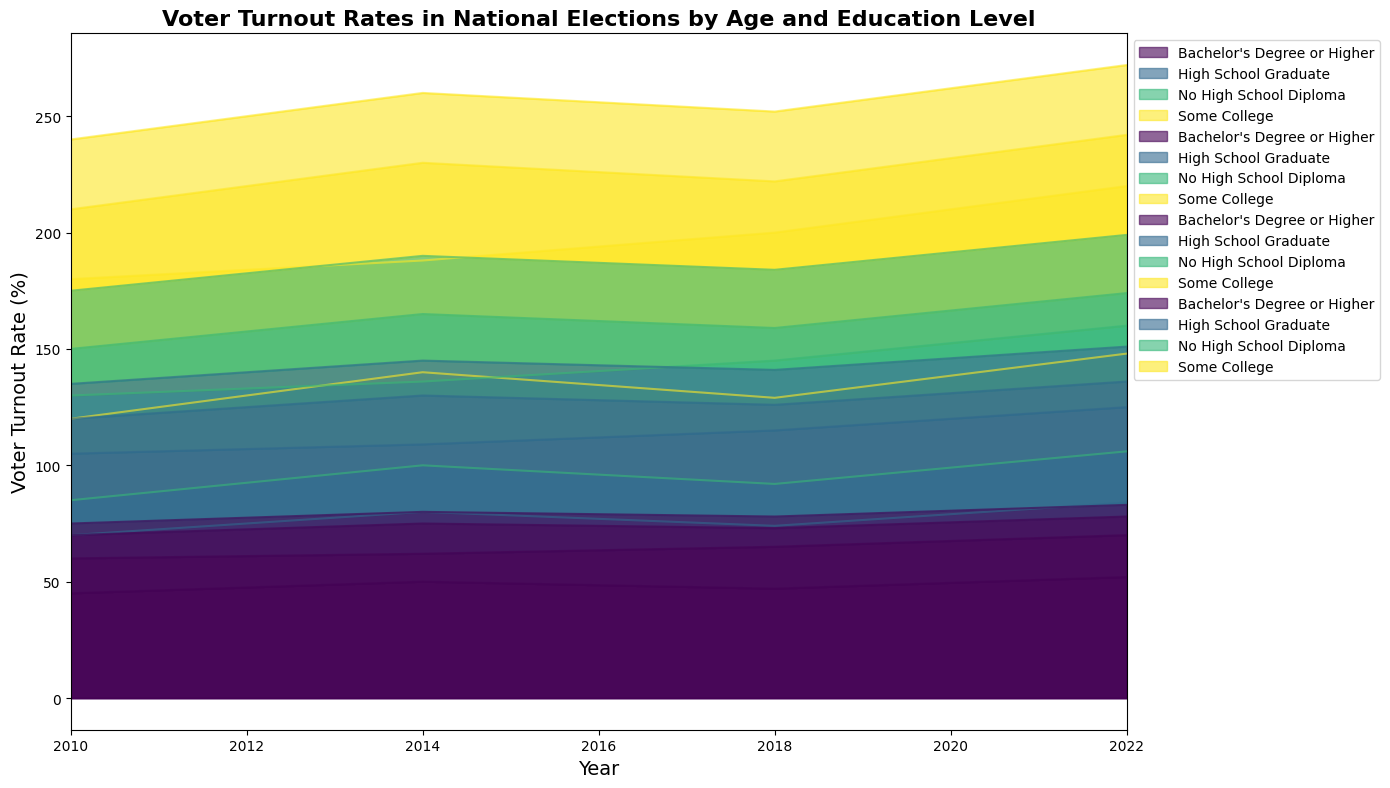What's the overall trend in voter turnout rates over the years for the 18-29 age group with no high school diploma? To determine the trend, look at the area representing the 18-29 age group with no high school diploma on the chart from 2010 to 2022. We can observe the color section related to this group. From 2010 to 2022, the rate shows an increase from 15.0% in 2010 to 22.0% in 2022.
Answer: Increasing How does the voter turnout rate of 60+ age group with a Bachelor's degree or higher in 2022 compare to the turnout rate of the same group in 2010? Identify the area representing the 60+ age group with a Bachelor's degree or higher in the years 2022 and 2010. The turnout rate for this group in 2010 is 75.0% and in 2022 is 83.0%.
Answer: Higher in 2022 Which education level saw the most significant increase in voter turnout for the 30-44 age group from 2010 to 2022? Examine the voter turnout rates for each education level within the 30-44 age group over the years. Calculate the rate of change for each education level between 2010 and 2022. The increases are: No HS Diploma (35.0 - 25.0) = 10.0, HS Graduate (55.0 - 45.0) = 10.0, Some College (60.0 - 50.0) = 10.0, Bachelor's Degree or Higher (70.0 - 60.0) = 10.0.
Answer: All levels saw significant increases of 10.0% What was the difference in voter turnout rates between the 45-59 age group with some college education and the 60+ age group with no high school diploma in 2018? For 2018, find the voter turnout rate for the 45-59 age group with some college education, which is 63.0%, and the rate for the 60+ age group with no high school diploma, which is 43.0%. Then, calculate the difference: 63.0 - 43.0 = 20.0.
Answer: 20.0% In 2022, which age group had the highest voter turnout rate for individuals with a high school diploma? Examine the voter turnout rates in 2022 for each age group with a high school diploma. The rates are: 18-29 (32.0%), 30-44 (55.0%), 45-59 (58.0%), 60+ (68.0%). The highest is the 60+ age group.
Answer: 60+ What's the average voter turnout rate for the 45-59 age group across all education levels in 2014? Find the voter turnout rates for each education level within the 45-59 age group in 2014: No HS Diploma (35.0), HS Graduate (55.0), Some College (65.0), Bachelor's Degree or Higher (75.0). Sum these values and divide by the number of education levels: (35.0 + 55.0 + 65.0 + 75.0) / 4 = 230.0 / 4 = 57.5.
Answer: 57.5 Which age group experienced the smallest change in voter turnout rates for individuals with some college education from 2010 to 2022? To determine the smallest change, calculate the change in voter turnout rates for each age group with some college education between 2010 and 2022: 18-29 (42.0 - 35.0) = 7.0, 30-44 (60.0 - 50.0) = 10.0, 45-59 (68.0 - 60.0) = 8.0, 60+ (73.0 - 65.0) = 8.0. The smallest change is for the 18-29 age group.
Answer: 18-29 